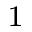<formula> <loc_0><loc_0><loc_500><loc_500>^ { 1 }</formula> 